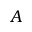<formula> <loc_0><loc_0><loc_500><loc_500>A</formula> 